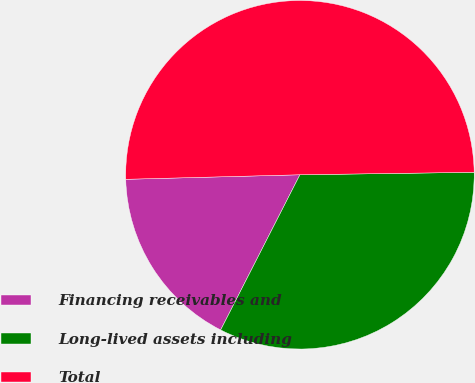<chart> <loc_0><loc_0><loc_500><loc_500><pie_chart><fcel>Financing receivables and<fcel>Long-lived assets including<fcel>Total<nl><fcel>17.07%<fcel>32.74%<fcel>50.19%<nl></chart> 